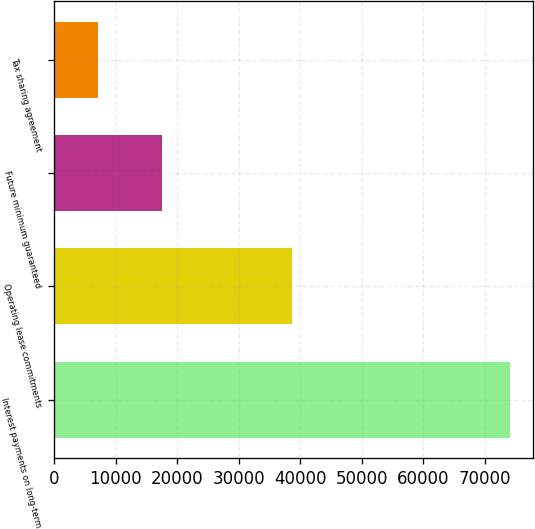Convert chart to OTSL. <chart><loc_0><loc_0><loc_500><loc_500><bar_chart><fcel>Interest payments on long-term<fcel>Operating lease commitments<fcel>Future minimum guaranteed<fcel>Tax sharing agreement<nl><fcel>74069<fcel>38665<fcel>17560<fcel>7100<nl></chart> 